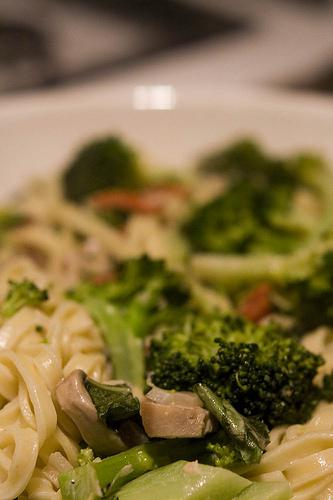Question: what color are the noodles?
Choices:
A. White.
B. Yellow.
C. Green.
D. Red.
Answer with the letter. Answer: A Question: who will eat this?
Choices:
A. A dog.
B. A cat.
C. A mouse.
D. A person.
Answer with the letter. Answer: D Question: how will this be consumed?
Choices:
A. By IV.
B. Up the nose.
C. By a stomach tube.
D. By mouth.
Answer with the letter. Answer: D 